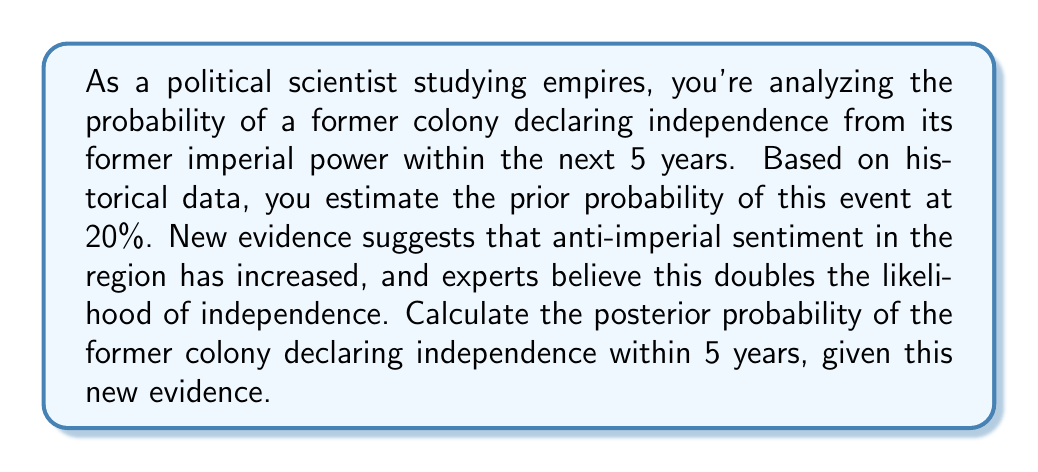Solve this math problem. To solve this problem, we'll use Bayes' theorem, which is expressed as:

$$P(A|B) = \frac{P(B|A) \cdot P(A)}{P(B)}$$

Where:
$A$ is the event of the former colony declaring independence within 5 years
$B$ is the new evidence of increased anti-imperial sentiment

Given:
- Prior probability: $P(A) = 0.20$
- The likelihood doubles given the new evidence: $P(B|A) = 2 \cdot P(B|\neg A)$

Step 1: Calculate $P(B)$ using the law of total probability
$$P(B) = P(B|A) \cdot P(A) + P(B|\neg A) \cdot P(\neg A)$$

Let $x = P(B|\neg A)$, then $P(B|A) = 2x$

$$P(B) = 2x \cdot 0.20 + x \cdot 0.80 = 0.40x + 0.80x = 1.20x$$

Step 2: Apply Bayes' theorem

$$P(A|B) = \frac{P(B|A) \cdot P(A)}{P(B)} = \frac{2x \cdot 0.20}{1.20x} = \frac{0.40}{1.20} = \frac{1}{3}$$

Therefore, the posterior probability of the former colony declaring independence within 5 years, given the new evidence, is $\frac{1}{3}$ or approximately 0.3333 or 33.33%.
Answer: $\frac{1}{3}$ or approximately 0.3333 or 33.33% 